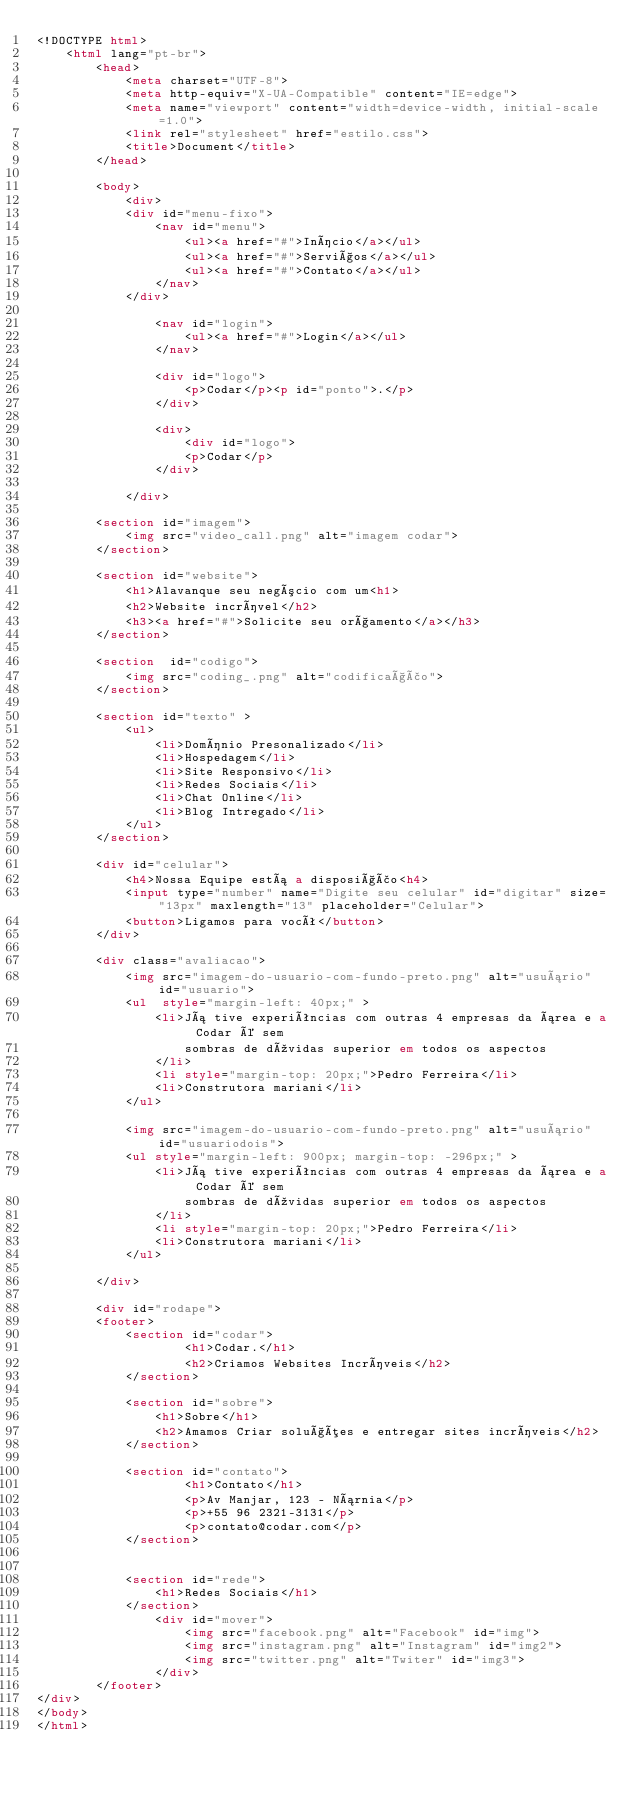<code> <loc_0><loc_0><loc_500><loc_500><_HTML_><!DOCTYPE html>
    <html lang="pt-br">
        <head>
            <meta charset="UTF-8">
            <meta http-equiv="X-UA-Compatible" content="IE=edge">
            <meta name="viewport" content="width=device-width, initial-scale=1.0">
            <link rel="stylesheet" href="estilo.css">
            <title>Document</title>
        </head>

        <body>
            <div>
            <div id="menu-fixo">
                <nav id="menu">
                    <ul><a href="#">Início</a></ul>
                    <ul><a href="#">Serviços</a></ul>
                    <ul><a href="#">Contato</a></ul>
                </nav>
            </div>

                <nav id="login">
                    <ul><a href="#">Login</a></ul>
                </nav>

                <div id="logo">
                    <p>Codar</p><p id="ponto">.</p>
                </div>

                <div>
                    <div id="logo">
                    <p>Codar</p>
                </div>

            </div>

        <section id="imagem">
            <img src="video_call.png" alt="imagem codar">
        </section>

        <section id="website">
            <h1>Alavanque seu negócio com um<h1>
            <h2>Website incrível</h2>
            <h3><a href="#">Solicite seu orçamento</a></h3>
        </section>

        <section  id="codigo">
            <img src="coding_.png" alt="codificação"> 
        </section>

        <section id="texto" >
            <ul> 
                <li>Domínio Presonalizado</li>
                <li>Hospedagem</li>
                <li>Site Responsivo</li>
                <li>Redes Sociais</li>
                <li>Chat Online</li>
                <li>Blog Intregado</li>
            </ul>
        </section>

        <div id="celular">
            <h4>Nossa Equipe está a disposição<h4>
            <input type="number" name="Digite seu celular" id="digitar" size="13px" maxlength="13" placeholder="Celular">
            <button>Ligamos para você</button>
        </div>

        <div class="avaliacao">
            <img src="imagem-do-usuario-com-fundo-preto.png" alt="usuário" id="usuario">
            <ul  style="margin-left: 40px;" >
                <li>Já tive experiências com outras 4 empresas da área e a Codar é sem 
                    sombras de dúvidas superior em todos os aspectos
                </li>
                <li style="margin-top: 20px;">Pedro Ferreira</li>
                <li>Construtora mariani</li>
            </ul>

            <img src="imagem-do-usuario-com-fundo-preto.png" alt="usuário" id="usuariodois">
            <ul style="margin-left: 900px; margin-top: -296px;" >
                <li>Já tive experiências com outras 4 empresas da área e a Codar é sem 
                    sombras de dúvidas superior em todos os aspectos
                </li>
                <li style="margin-top: 20px;">Pedro Ferreira</li>
                <li>Construtora mariani</li>
            </ul>

        </div>

        <div id="rodape">
        <footer>
            <section id="codar">
                    <h1>Codar.</h1>
                    <h2>Criamos Websites Incríveis</h2>
            </section>
                    
            <section id="sobre">
                <h1>Sobre</h1>
                <h2>Amamos Criar soluções e entregar sites incríveis</h2>
            </section>

            <section id="contato">
                    <h1>Contato</h1>
                    <p>Av Manjar, 123 - Nárnia</p>
                    <p>+55 96 2321-3131</p>
                    <p>contato@codar.com</p>
            </section>

            
            <section id="rede">
                <h1>Redes Sociais</h1>
            </section>
                <div id="mover">
                    <img src="facebook.png" alt="Facebook" id="img">
                    <img src="instagram.png" alt="Instagram" id="img2">
                    <img src="twitter.png" alt="Twiter" id="img3">
                </div>
        </footer>
</div>
</body>
</html></code> 